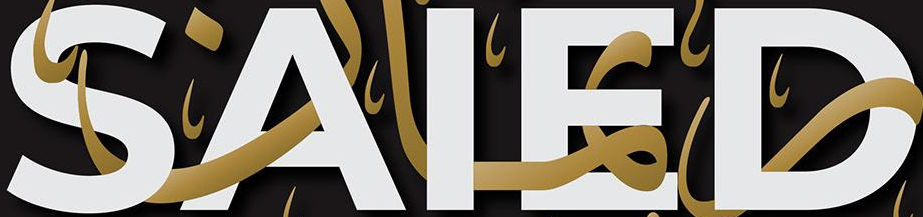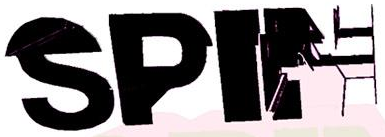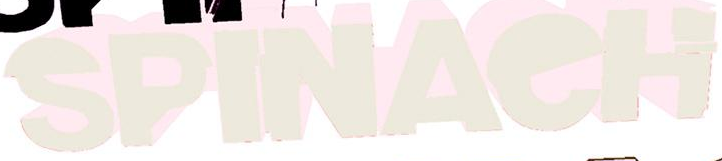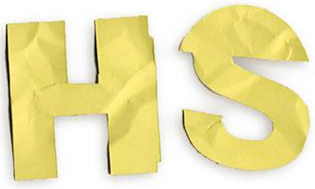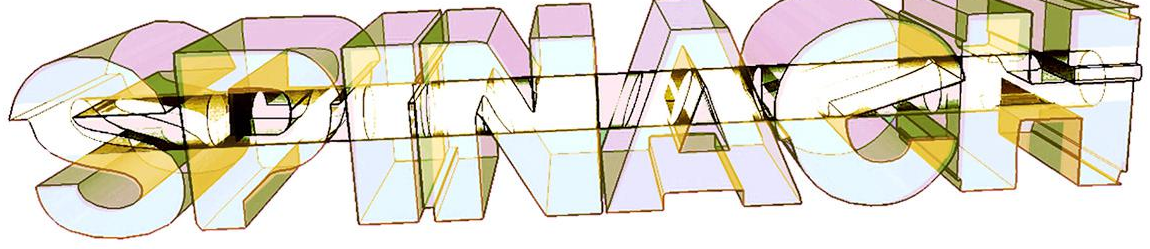Transcribe the words shown in these images in order, separated by a semicolon. SAIED; SPIN; SPINAeH; HS; SPINAeH 